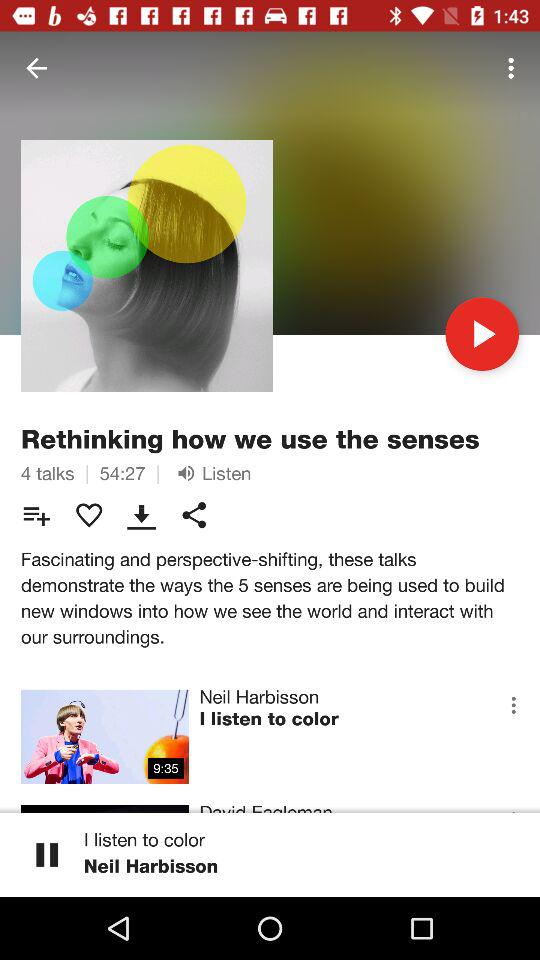How many talks are on this page?
Answer the question using a single word or phrase. 4 